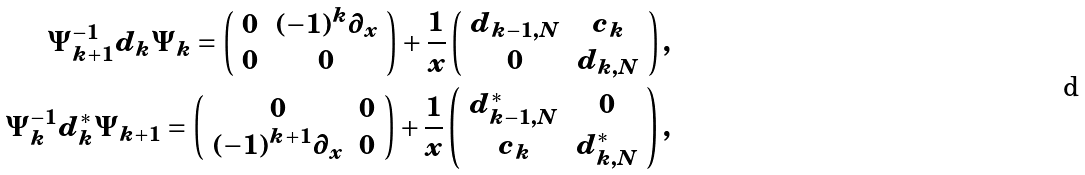<formula> <loc_0><loc_0><loc_500><loc_500>\Psi _ { k + 1 } ^ { - 1 } d _ { k } \Psi _ { k } = \left ( \begin{array} { c c } 0 & ( - 1 ) ^ { k } \partial _ { x } \\ 0 & 0 \end{array} \right ) + \frac { 1 } { x } \left ( \begin{array} { c c } d _ { k - 1 , N } & c _ { k } \\ 0 & d _ { k , N } \end{array} \right ) , \\ \Psi _ { k } ^ { - 1 } d _ { k } ^ { * } \Psi _ { k + 1 } = \left ( \begin{array} { c c } 0 & 0 \\ ( - 1 ) ^ { k + 1 } \partial _ { x } & 0 \end{array} \right ) + \frac { 1 } { x } \left ( \begin{array} { c c } d _ { k - 1 , N } ^ { * } & 0 \\ c _ { k } & d _ { k , N } ^ { * } \end{array} \right ) ,</formula> 